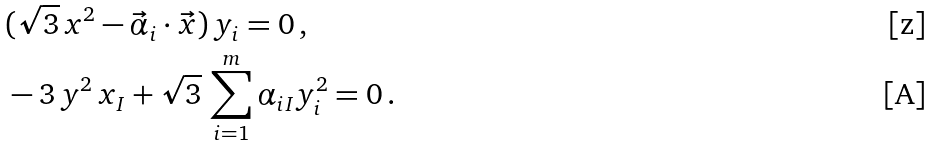Convert formula to latex. <formula><loc_0><loc_0><loc_500><loc_500>& ( \sqrt { 3 } \, x ^ { 2 } - \vec { \alpha } _ { i } \cdot \vec { x } ) \, y _ { i } = 0 \, , \\ & - 3 \, y ^ { 2 } \, x _ { I } + \sqrt { 3 } \, \sum _ { i = 1 } ^ { m } \alpha _ { i I } y ^ { 2 } _ { i } = 0 \, .</formula> 